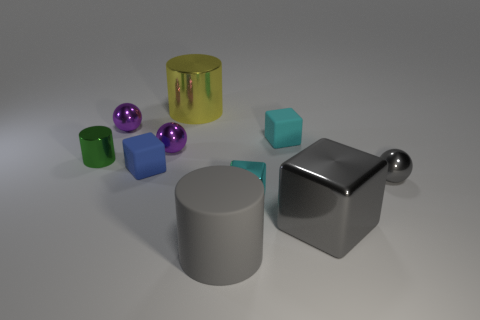Do the cyan rubber thing and the blue rubber cube have the same size?
Keep it short and to the point. Yes. Are any big objects visible?
Keep it short and to the point. Yes. Are there any tiny cylinders that have the same material as the tiny gray object?
Your response must be concise. Yes. There is a green thing that is the same size as the blue thing; what is its material?
Your answer should be compact. Metal. What number of big matte objects are the same shape as the tiny cyan rubber object?
Your answer should be compact. 0. There is a green cylinder that is the same material as the tiny gray object; what is its size?
Offer a terse response. Small. What material is the big thing that is both left of the tiny cyan rubber object and in front of the big yellow metallic object?
Ensure brevity in your answer.  Rubber. How many purple balls are the same size as the gray metal cube?
Your answer should be very brief. 0. There is another cyan thing that is the same shape as the cyan metallic object; what is it made of?
Offer a very short reply. Rubber. What number of objects are either big things that are to the right of the large matte cylinder or tiny balls that are to the left of the tiny cyan metal thing?
Your answer should be compact. 3. 